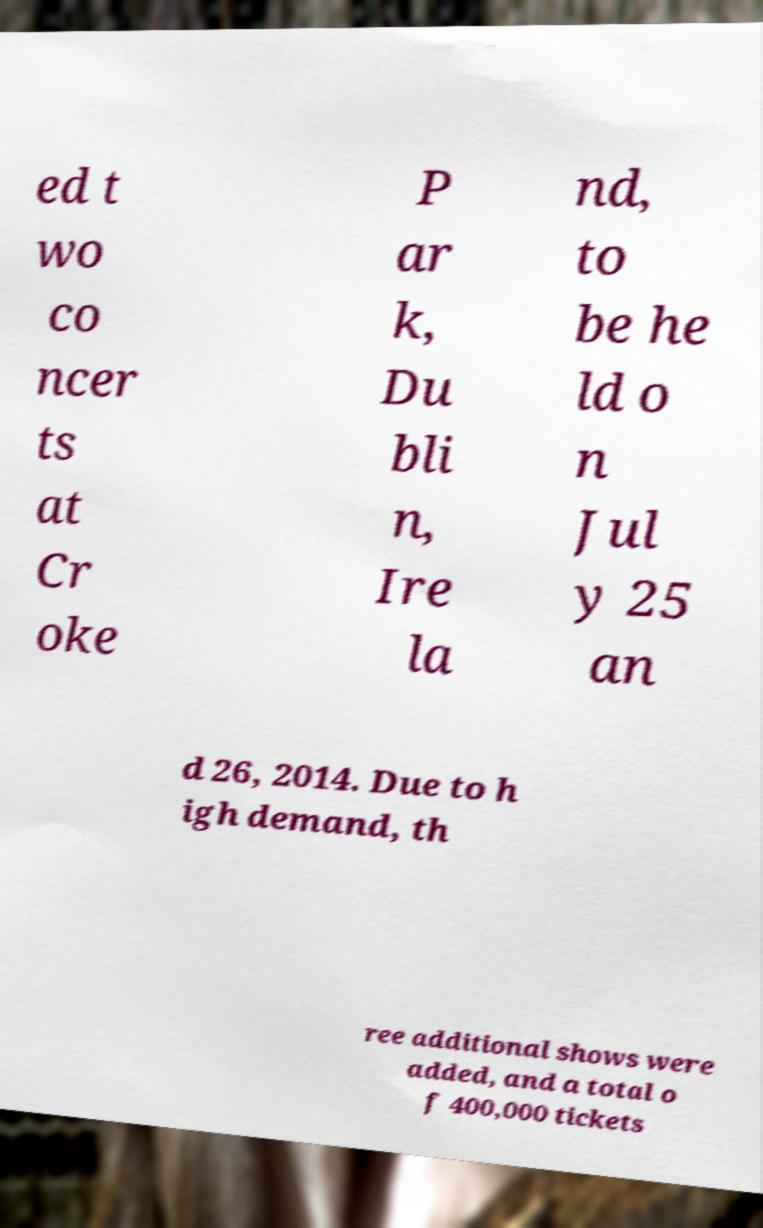Could you assist in decoding the text presented in this image and type it out clearly? ed t wo co ncer ts at Cr oke P ar k, Du bli n, Ire la nd, to be he ld o n Jul y 25 an d 26, 2014. Due to h igh demand, th ree additional shows were added, and a total o f 400,000 tickets 